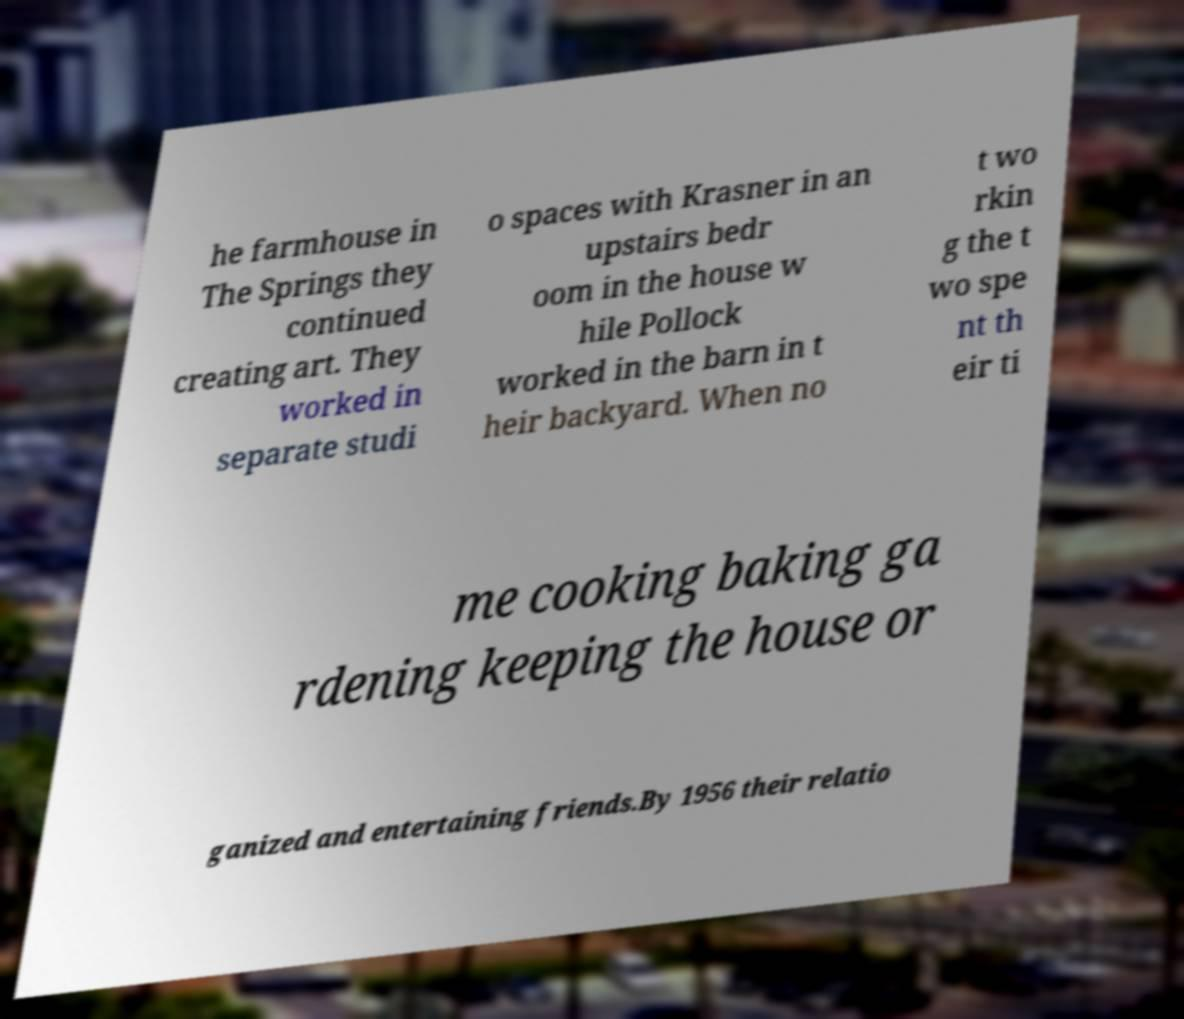Could you extract and type out the text from this image? he farmhouse in The Springs they continued creating art. They worked in separate studi o spaces with Krasner in an upstairs bedr oom in the house w hile Pollock worked in the barn in t heir backyard. When no t wo rkin g the t wo spe nt th eir ti me cooking baking ga rdening keeping the house or ganized and entertaining friends.By 1956 their relatio 